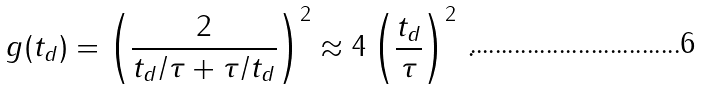Convert formula to latex. <formula><loc_0><loc_0><loc_500><loc_500>g ( t _ { d } ) = \left ( \frac { 2 } { t _ { d } / \tau + \tau / t _ { d } } \right ) ^ { 2 } \approx 4 \left ( \frac { t _ { d } } { \tau } \right ) ^ { 2 } \, .</formula> 